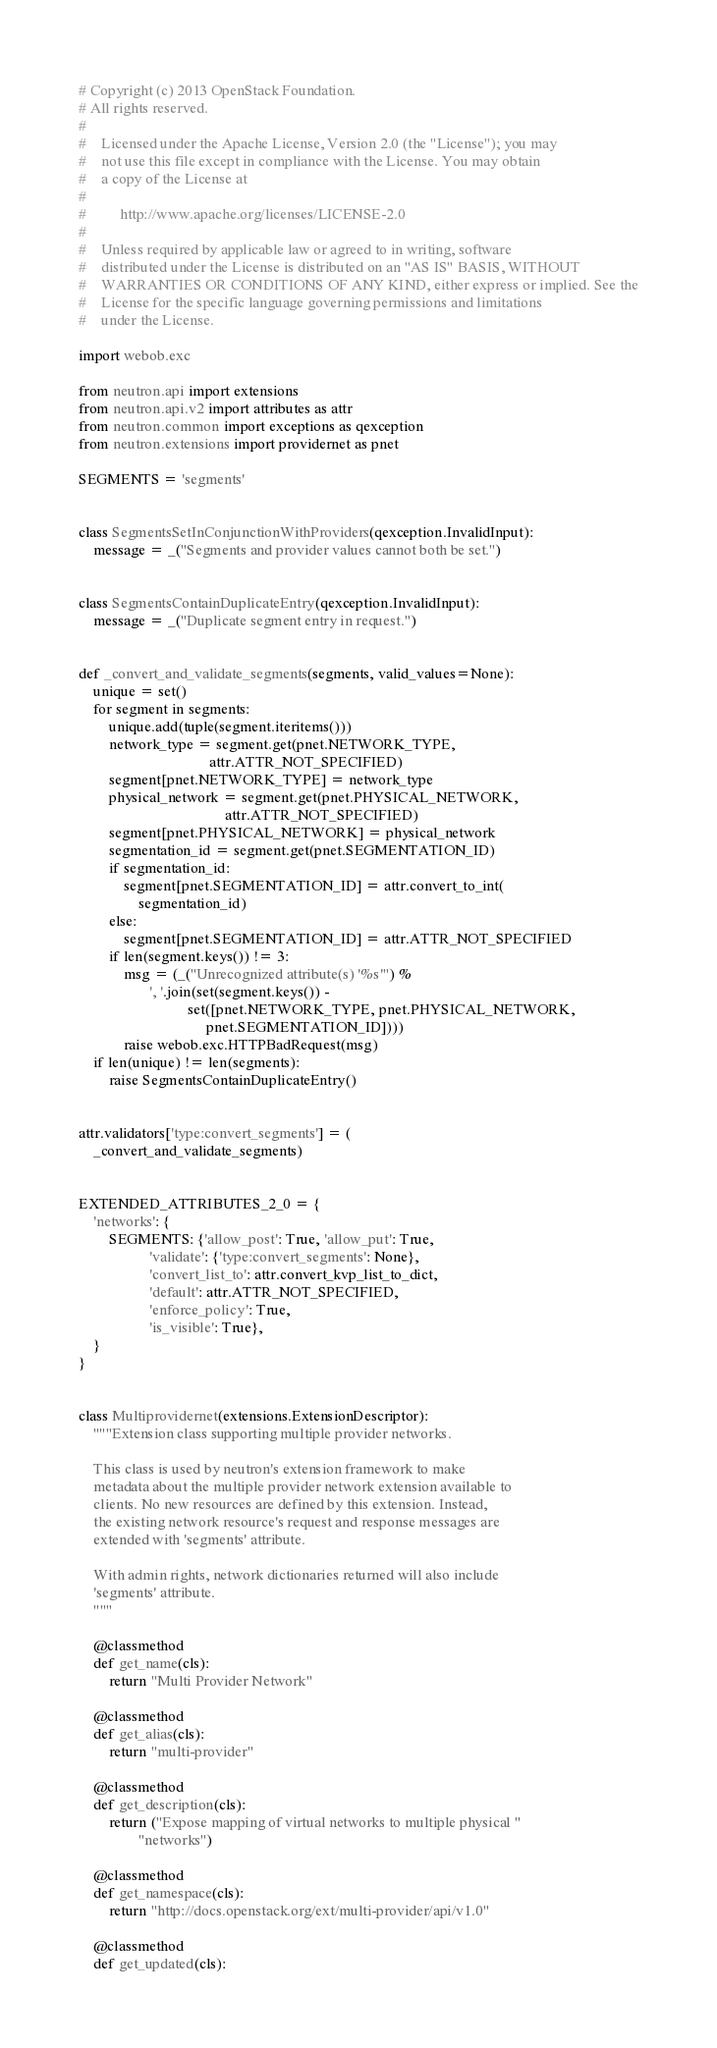<code> <loc_0><loc_0><loc_500><loc_500><_Python_># Copyright (c) 2013 OpenStack Foundation.
# All rights reserved.
#
#    Licensed under the Apache License, Version 2.0 (the "License"); you may
#    not use this file except in compliance with the License. You may obtain
#    a copy of the License at
#
#         http://www.apache.org/licenses/LICENSE-2.0
#
#    Unless required by applicable law or agreed to in writing, software
#    distributed under the License is distributed on an "AS IS" BASIS, WITHOUT
#    WARRANTIES OR CONDITIONS OF ANY KIND, either express or implied. See the
#    License for the specific language governing permissions and limitations
#    under the License.

import webob.exc

from neutron.api import extensions
from neutron.api.v2 import attributes as attr
from neutron.common import exceptions as qexception
from neutron.extensions import providernet as pnet

SEGMENTS = 'segments'


class SegmentsSetInConjunctionWithProviders(qexception.InvalidInput):
    message = _("Segments and provider values cannot both be set.")


class SegmentsContainDuplicateEntry(qexception.InvalidInput):
    message = _("Duplicate segment entry in request.")


def _convert_and_validate_segments(segments, valid_values=None):
    unique = set()
    for segment in segments:
        unique.add(tuple(segment.iteritems()))
        network_type = segment.get(pnet.NETWORK_TYPE,
                                   attr.ATTR_NOT_SPECIFIED)
        segment[pnet.NETWORK_TYPE] = network_type
        physical_network = segment.get(pnet.PHYSICAL_NETWORK,
                                       attr.ATTR_NOT_SPECIFIED)
        segment[pnet.PHYSICAL_NETWORK] = physical_network
        segmentation_id = segment.get(pnet.SEGMENTATION_ID)
        if segmentation_id:
            segment[pnet.SEGMENTATION_ID] = attr.convert_to_int(
                segmentation_id)
        else:
            segment[pnet.SEGMENTATION_ID] = attr.ATTR_NOT_SPECIFIED
        if len(segment.keys()) != 3:
            msg = (_("Unrecognized attribute(s) '%s'") %
                   ', '.join(set(segment.keys()) -
                             set([pnet.NETWORK_TYPE, pnet.PHYSICAL_NETWORK,
                                  pnet.SEGMENTATION_ID])))
            raise webob.exc.HTTPBadRequest(msg)
    if len(unique) != len(segments):
        raise SegmentsContainDuplicateEntry()


attr.validators['type:convert_segments'] = (
    _convert_and_validate_segments)


EXTENDED_ATTRIBUTES_2_0 = {
    'networks': {
        SEGMENTS: {'allow_post': True, 'allow_put': True,
                   'validate': {'type:convert_segments': None},
                   'convert_list_to': attr.convert_kvp_list_to_dict,
                   'default': attr.ATTR_NOT_SPECIFIED,
                   'enforce_policy': True,
                   'is_visible': True},
    }
}


class Multiprovidernet(extensions.ExtensionDescriptor):
    """Extension class supporting multiple provider networks.

    This class is used by neutron's extension framework to make
    metadata about the multiple provider network extension available to
    clients. No new resources are defined by this extension. Instead,
    the existing network resource's request and response messages are
    extended with 'segments' attribute.

    With admin rights, network dictionaries returned will also include
    'segments' attribute.
    """

    @classmethod
    def get_name(cls):
        return "Multi Provider Network"

    @classmethod
    def get_alias(cls):
        return "multi-provider"

    @classmethod
    def get_description(cls):
        return ("Expose mapping of virtual networks to multiple physical "
                "networks")

    @classmethod
    def get_namespace(cls):
        return "http://docs.openstack.org/ext/multi-provider/api/v1.0"

    @classmethod
    def get_updated(cls):</code> 